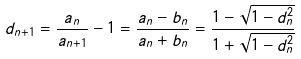Convert formula to latex. <formula><loc_0><loc_0><loc_500><loc_500>d _ { n + 1 } = \frac { a _ { n } } { a _ { n + 1 } } - 1 = \frac { a _ { n } - b _ { n } } { a _ { n } + b _ { n } } = \frac { 1 - \sqrt { 1 - d _ { n } ^ { 2 } } } { 1 + \sqrt { 1 - d _ { n } ^ { 2 } } }</formula> 